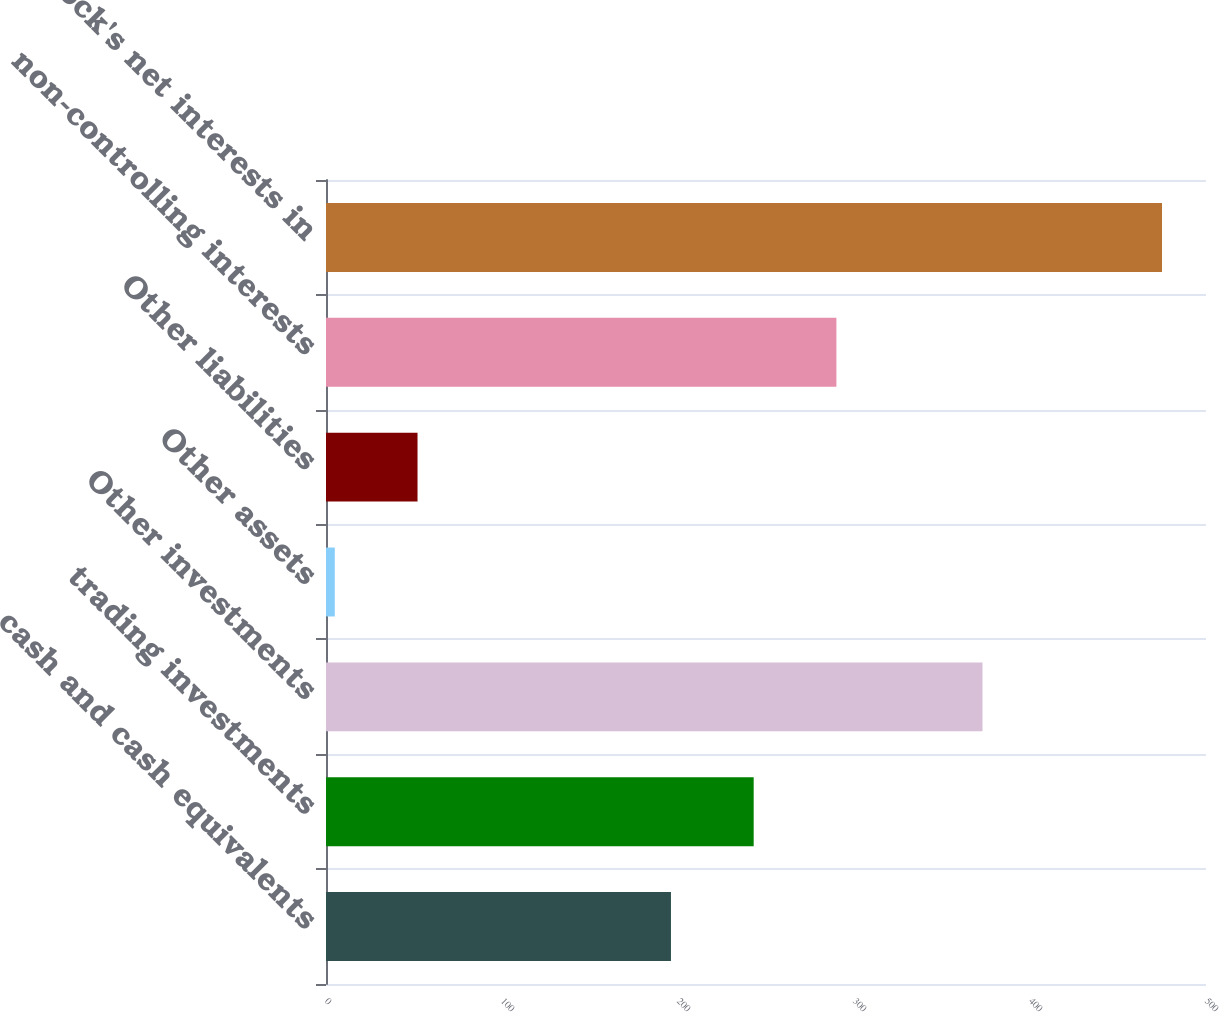Convert chart to OTSL. <chart><loc_0><loc_0><loc_500><loc_500><bar_chart><fcel>cash and cash equivalents<fcel>trading investments<fcel>Other investments<fcel>Other assets<fcel>Other liabilities<fcel>non-controlling interests<fcel>BlackRock's net interests in<nl><fcel>196<fcel>243<fcel>373<fcel>5<fcel>52<fcel>290<fcel>475<nl></chart> 